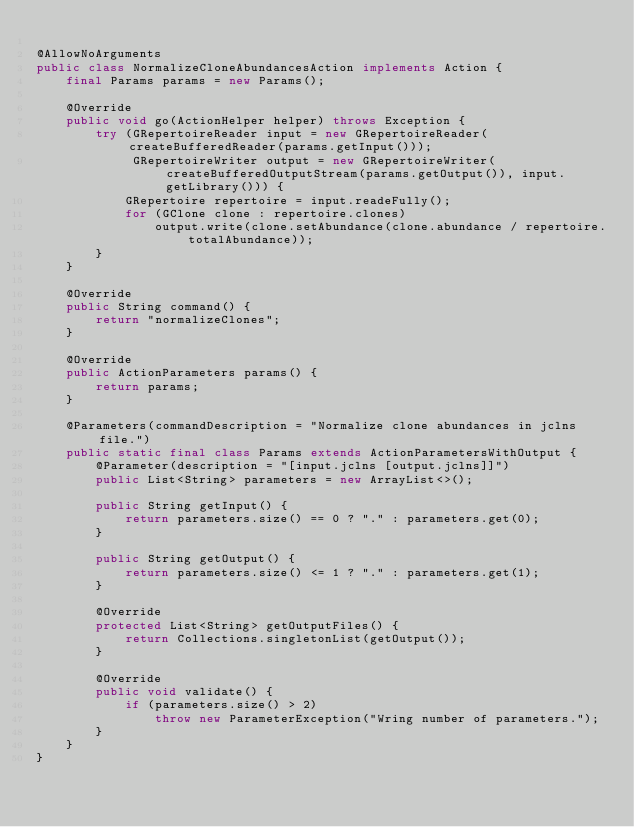Convert code to text. <code><loc_0><loc_0><loc_500><loc_500><_Java_>
@AllowNoArguments
public class NormalizeCloneAbundancesAction implements Action {
    final Params params = new Params();

    @Override
    public void go(ActionHelper helper) throws Exception {
        try (GRepertoireReader input = new GRepertoireReader(createBufferedReader(params.getInput()));
             GRepertoireWriter output = new GRepertoireWriter(createBufferedOutputStream(params.getOutput()), input.getLibrary())) {
            GRepertoire repertoire = input.readeFully();
            for (GClone clone : repertoire.clones)
                output.write(clone.setAbundance(clone.abundance / repertoire.totalAbundance));
        }
    }

    @Override
    public String command() {
        return "normalizeClones";
    }

    @Override
    public ActionParameters params() {
        return params;
    }

    @Parameters(commandDescription = "Normalize clone abundances in jclns file.")
    public static final class Params extends ActionParametersWithOutput {
        @Parameter(description = "[input.jclns [output.jclns]]")
        public List<String> parameters = new ArrayList<>();

        public String getInput() {
            return parameters.size() == 0 ? "." : parameters.get(0);
        }

        public String getOutput() {
            return parameters.size() <= 1 ? "." : parameters.get(1);
        }

        @Override
        protected List<String> getOutputFiles() {
            return Collections.singletonList(getOutput());
        }

        @Override
        public void validate() {
            if (parameters.size() > 2)
                throw new ParameterException("Wring number of parameters.");
        }
    }
}
</code> 